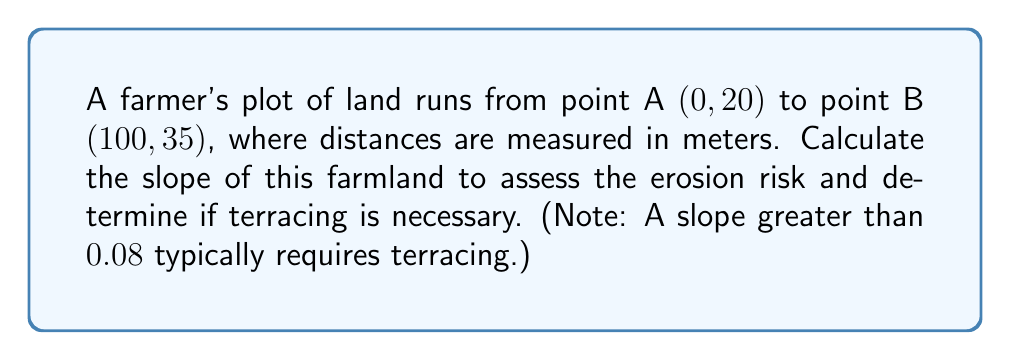Help me with this question. To determine the slope of the farmland, we'll use the slope formula:

$$ \text{slope} = \frac{y_2 - y_1}{x_2 - x_1} $$

Where $(x_1, y_1)$ is the first point and $(x_2, y_2)$ is the second point.

Given:
- Point A: (0, 20)
- Point B: (100, 35)

Step 1: Identify the coordinates
$x_1 = 0$, $y_1 = 20$
$x_2 = 100$, $y_2 = 35$

Step 2: Apply the slope formula
$$ \text{slope} = \frac{35 - 20}{100 - 0} = \frac{15}{100} = 0.15 $$

Step 3: Interpret the result
The slope of the farmland is 0.15, which is greater than 0.08. This indicates a significant risk of erosion, and terracing is recommended to mitigate this risk.

[asy]
unitsize(2mm);
draw((0,0)--(100,0), arrow=Arrow(TeXHead));
draw((0,0)--(0,40), arrow=Arrow(TeXHead));
draw((0,20)--(100,35), blue+1);
dot((0,20));
dot((100,35));
label("A (0, 20)", (0,20), SW);
label("B (100, 35)", (100,35), NE);
label("x (m)", (100,0), S);
label("y (m)", (0,40), W);
[/asy]
Answer: 0.15 